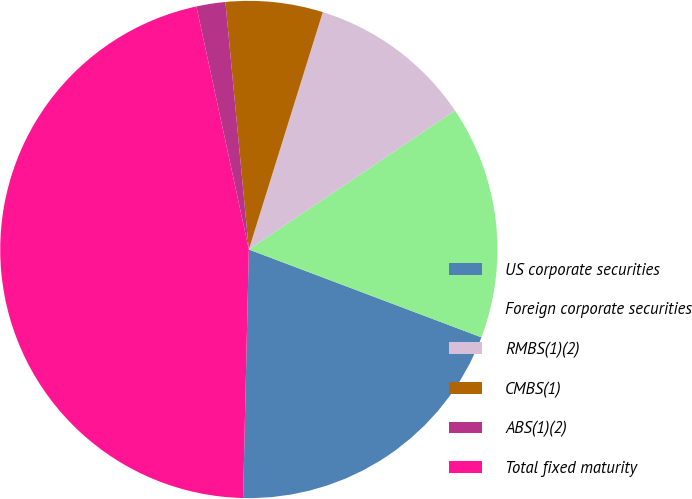<chart> <loc_0><loc_0><loc_500><loc_500><pie_chart><fcel>US corporate securities<fcel>Foreign corporate securities<fcel>RMBS(1)(2)<fcel>CMBS(1)<fcel>ABS(1)(2)<fcel>Total fixed maturity<nl><fcel>19.62%<fcel>15.19%<fcel>10.75%<fcel>6.31%<fcel>1.88%<fcel>46.25%<nl></chart> 